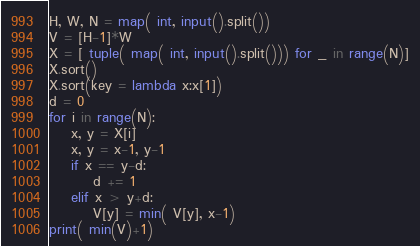Convert code to text. <code><loc_0><loc_0><loc_500><loc_500><_Python_>H, W, N = map( int, input().split())
V = [H-1]*W
X = [ tuple( map( int, input().split())) for _ in range(N)]
X.sort()
X.sort(key = lambda x:x[1])
d = 0
for i in range(N):
    x, y = X[i]
    x, y = x-1, y-1
    if x == y-d:
        d += 1
    elif x > y+d:
        V[y] = min( V[y], x-1)
print( min(V)+1)
</code> 